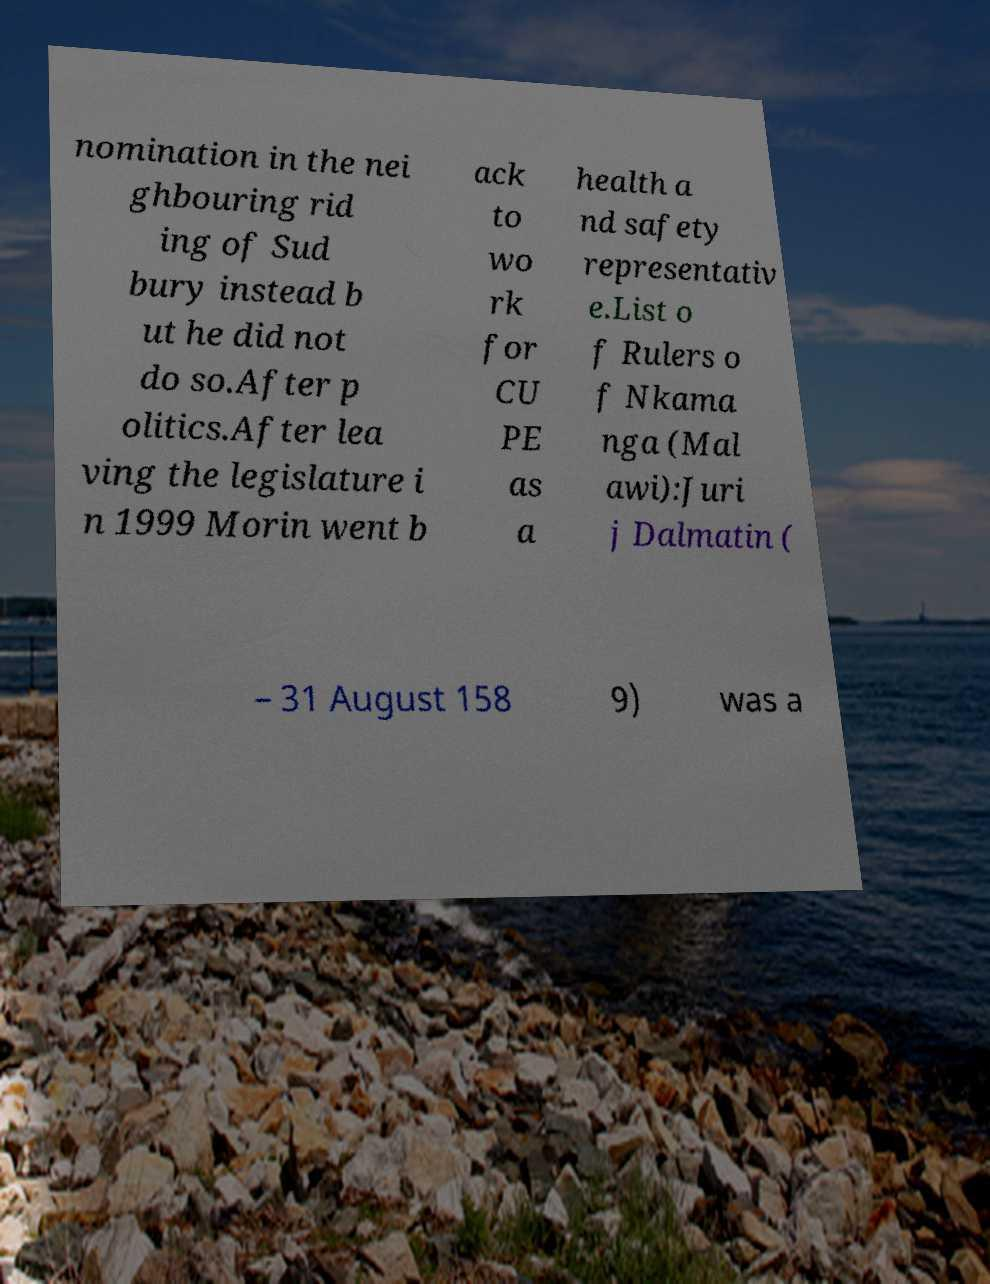There's text embedded in this image that I need extracted. Can you transcribe it verbatim? nomination in the nei ghbouring rid ing of Sud bury instead b ut he did not do so.After p olitics.After lea ving the legislature i n 1999 Morin went b ack to wo rk for CU PE as a health a nd safety representativ e.List o f Rulers o f Nkama nga (Mal awi):Juri j Dalmatin ( – 31 August 158 9) was a 